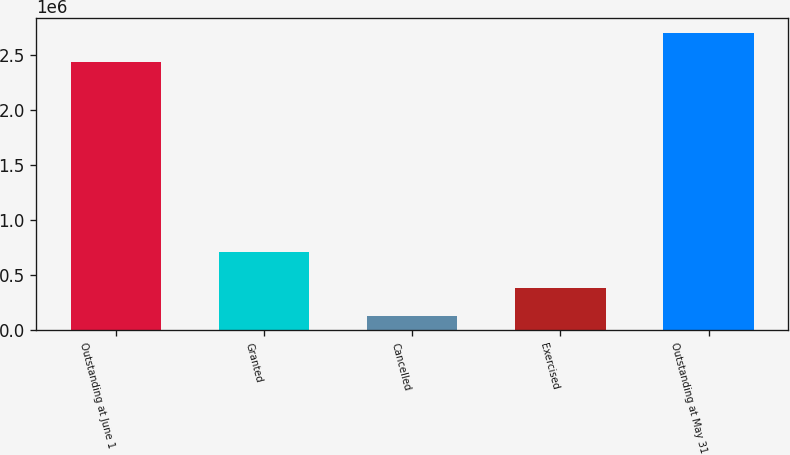Convert chart. <chart><loc_0><loc_0><loc_500><loc_500><bar_chart><fcel>Outstanding at June 1<fcel>Granted<fcel>Cancelled<fcel>Exercised<fcel>Outstanding at May 31<nl><fcel>2.441e+06<fcel>708768<fcel>124999<fcel>382533<fcel>2.70034e+06<nl></chart> 